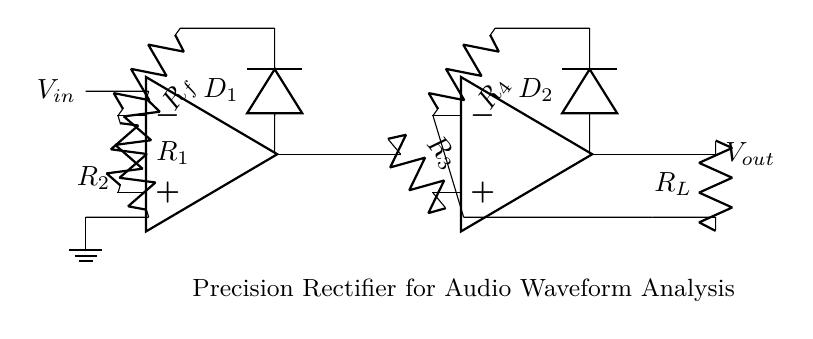What is the input voltage of this circuit? The input voltage, labeled as V_in, is the voltage that is applied at the beginning of the circuit and serves as the signal to be processed.
Answer: V_in What are the types of diodes used in this rectifier? The circuit shows two diodes labeled as D_1 and D_2, which are part of the precision rectifier setup, allowing current to flow in one direction only for each half of the input signal.
Answer: D_1 and D_2 What is the function of R_f in the circuit? The resistor R_f is part of the feedback loop for the first operational amplifier, helping to set the gain and ensuring the accuracy of the rectification process by stabilizing the output.
Answer: Feedback resistor What is the configuration of the operational amplifiers? The circuit shows a configuration where each operational amplifier is used as a comparator or amplifier, contributing to the precision rectification of the input audio waveform.
Answer: Two stages What is the purpose of the load resistor R_L? The load resistor R_L is connected to the output, allowing the processed signal to be measured or used in subsequent stages of the audio analysis tool, providing a pathway for current flow.
Answer: Output connection What is the overall purpose of this precision rectifier circuit? The circuit is designed to accurately convert both the positive and negative halves of an audio waveform input into a corresponding voltage signal, allowing for precise signal processing in audio analysis tools.
Answer: Signal processing 